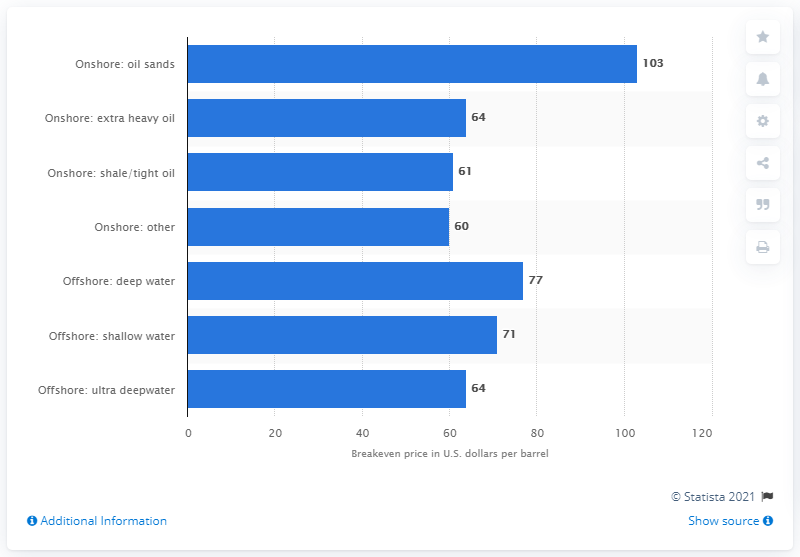Identify some key points in this picture. According to estimates, the expected production of new oil sands projects between 2014 and 2020 is expected to cost $103 per barrel or more to break even. 